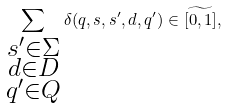<formula> <loc_0><loc_0><loc_500><loc_500>\sum _ { \substack { s ^ { \prime } \in \Sigma \\ d \in D \\ q ^ { \prime } \in Q } } \delta ( q , s , s ^ { \prime } , d , q ^ { \prime } ) \in \widetilde { [ 0 , 1 ] } ,</formula> 